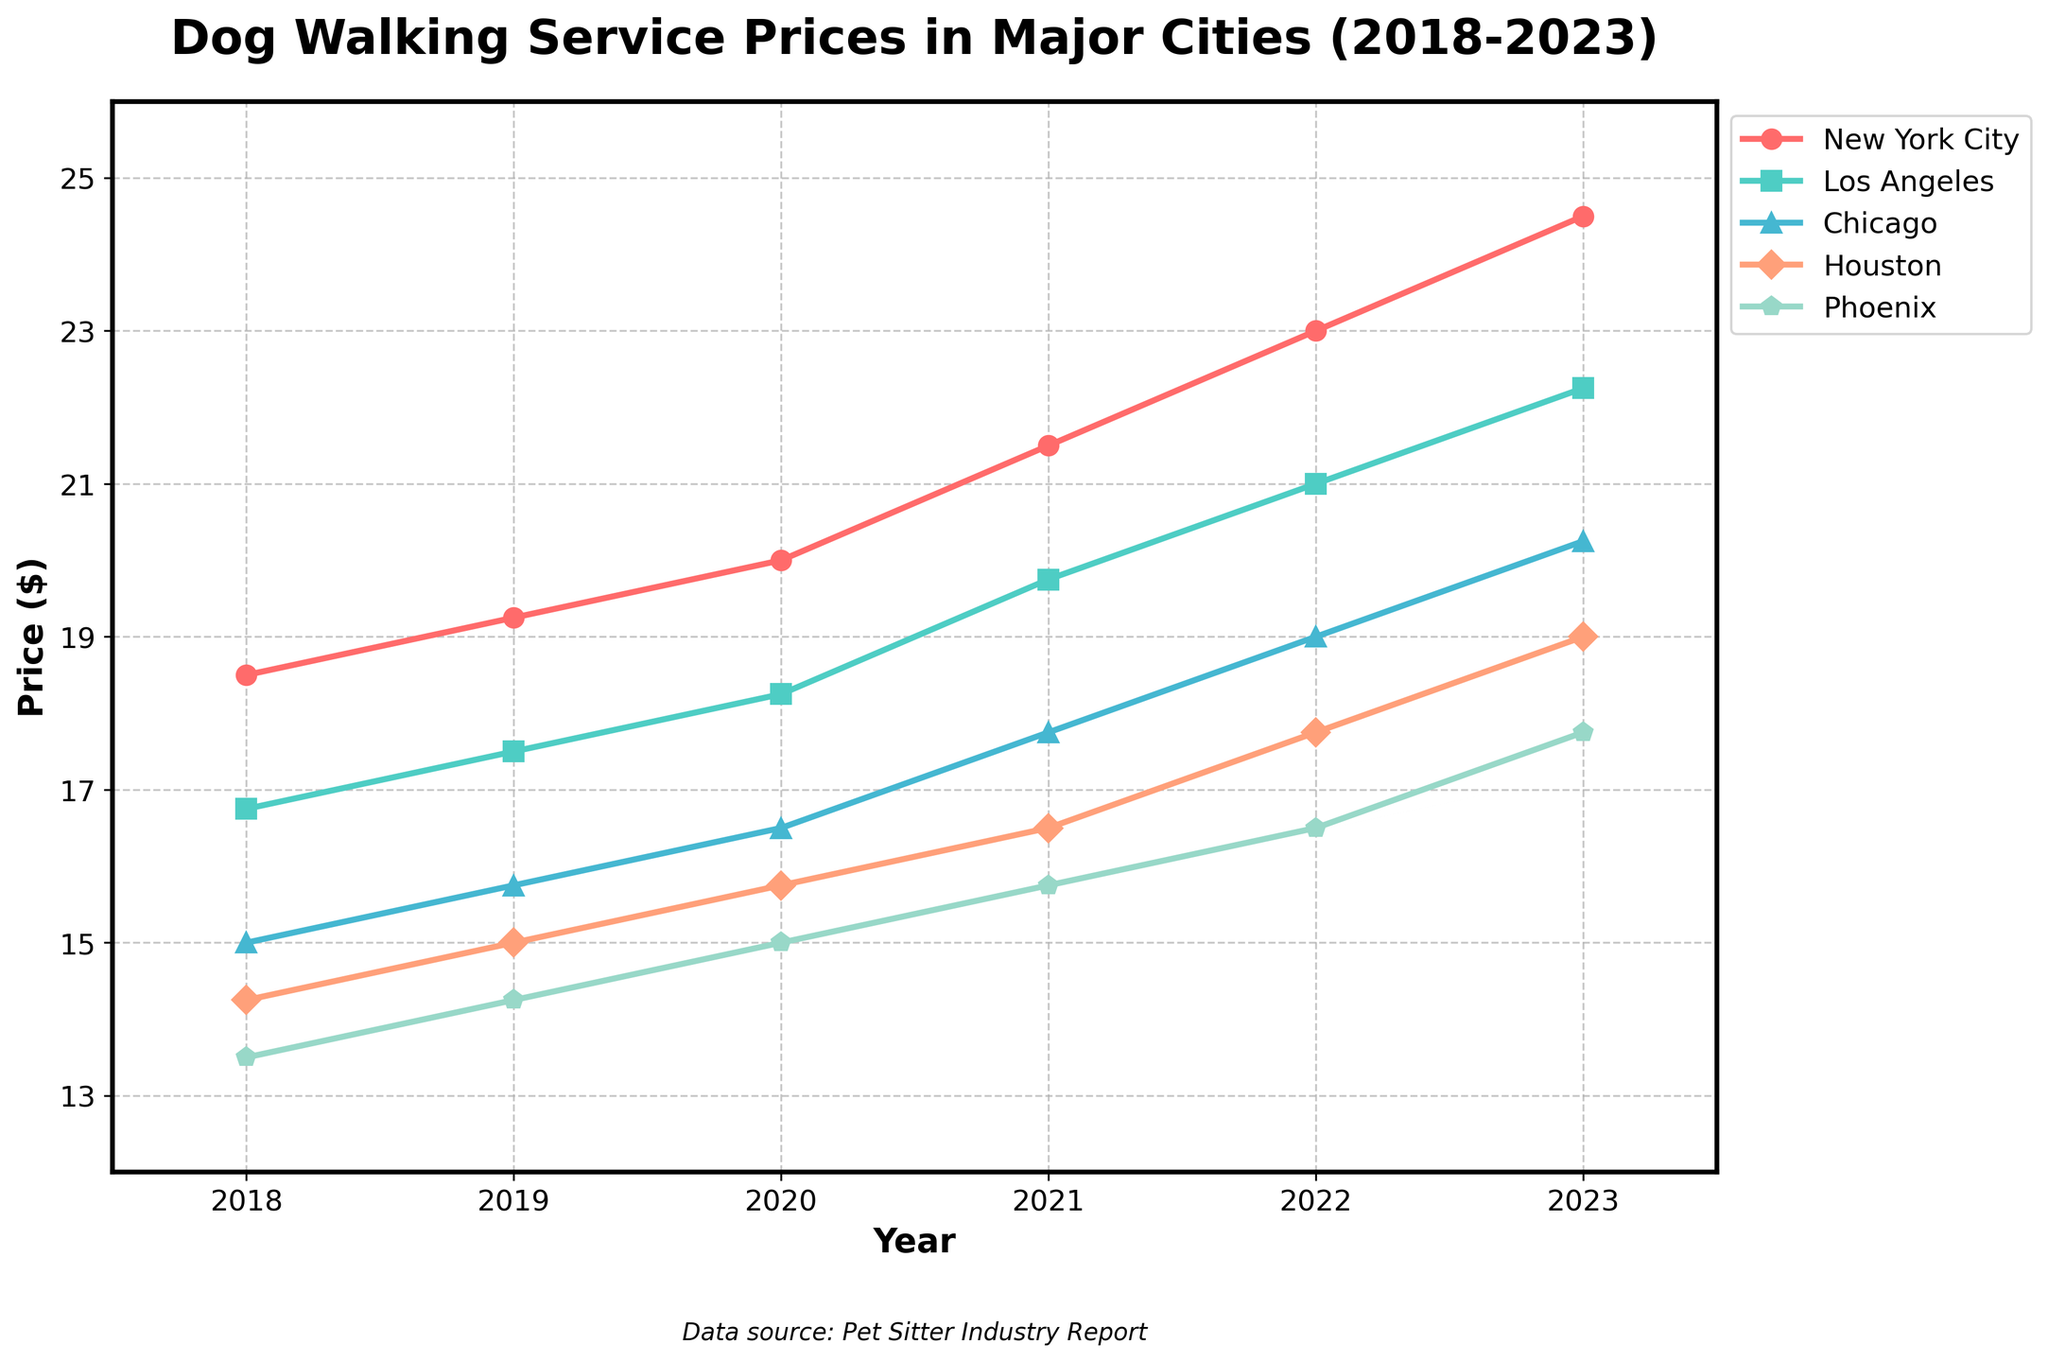What was the price difference of dog walking services between New York City and Houston in 2021? In 2021, the price for New York City was $21.50, and for Houston, it was $16.50. The difference is $21.50 - $16.50 = $5.00.
Answer: $5.00 Which city had the lowest price for dog walking services in 2019? In 2019, the prices were as follows: New York City ($19.25), Los Angeles ($17.50), Chicago ($15.75), Houston ($15.00), and Phoenix ($14.25). Phoenix had the lowest price at $14.25.
Answer: Phoenix How much did the price for dog walking services in Los Angeles increase from 2018 to 2023? The price in Los Angeles was $16.75 in 2018 and increased to $22.25 in 2023. The total increase is $22.25 - $16.75 = $5.50.
Answer: $5.50 In which city and year did the price surpass the $20 mark? The price surpassed the $20 mark in New York City in 2020 and Los Angeles in 2021.
Answer: New York City (2020) and Los Angeles (2021) Compare the prices in Chicago and Phoenix in 2023, which city had a higher price and by how much? In 2023, the price in Chicago was $20.25, and in Phoenix, it was $17.75. Chicago had a higher price by $20.25 - $17.75 = $2.50.
Answer: Chicago, $2.50 Calculate the average price for dog walking services in Houston over the years 2018-2023. The prices in Houston from 2018 to 2023 were $14.25, $15.00, $15.75, $16.50, $17.75, and $19.00. The average is ($14.25 + $15.00 + $15.75 + $16.50 + $17.75 + $19.00) / 6 = $16.7083.
Answer: $16.71 What is the price trend for dog walking services in New York City from 2018 to 2023? The price in New York City shows a consistent upward trend each year: $18.50 (2018), $19.25 (2019), $20.00 (2020), $21.50 (2021), $23.00 (2022), $24.50 (2023).
Answer: Increasing 